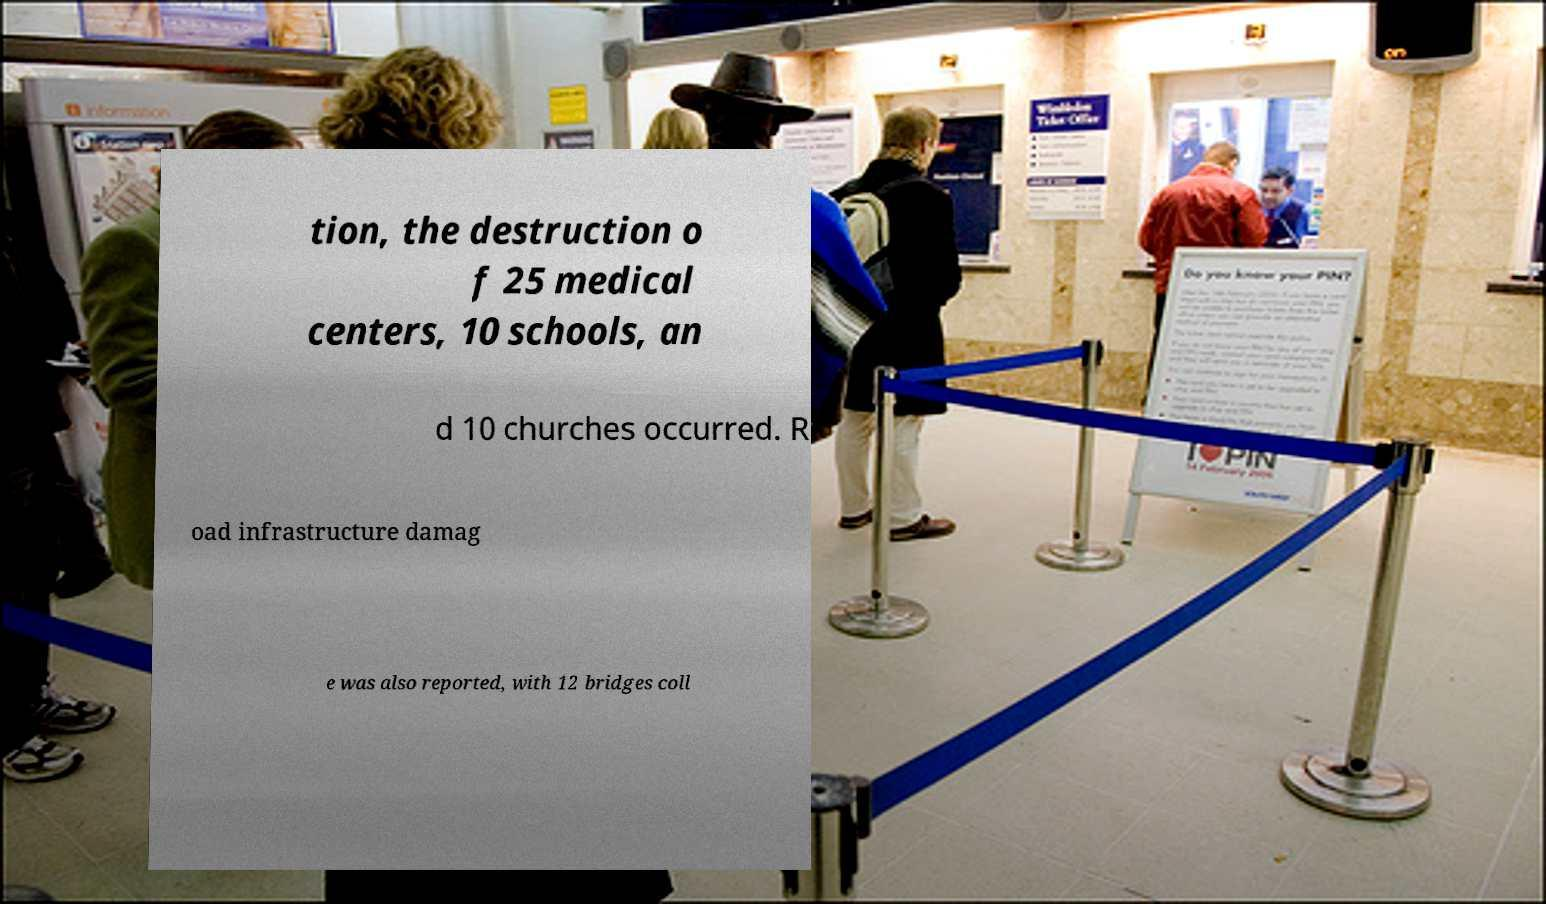Please read and relay the text visible in this image. What does it say? tion, the destruction o f 25 medical centers, 10 schools, an d 10 churches occurred. R oad infrastructure damag e was also reported, with 12 bridges coll 